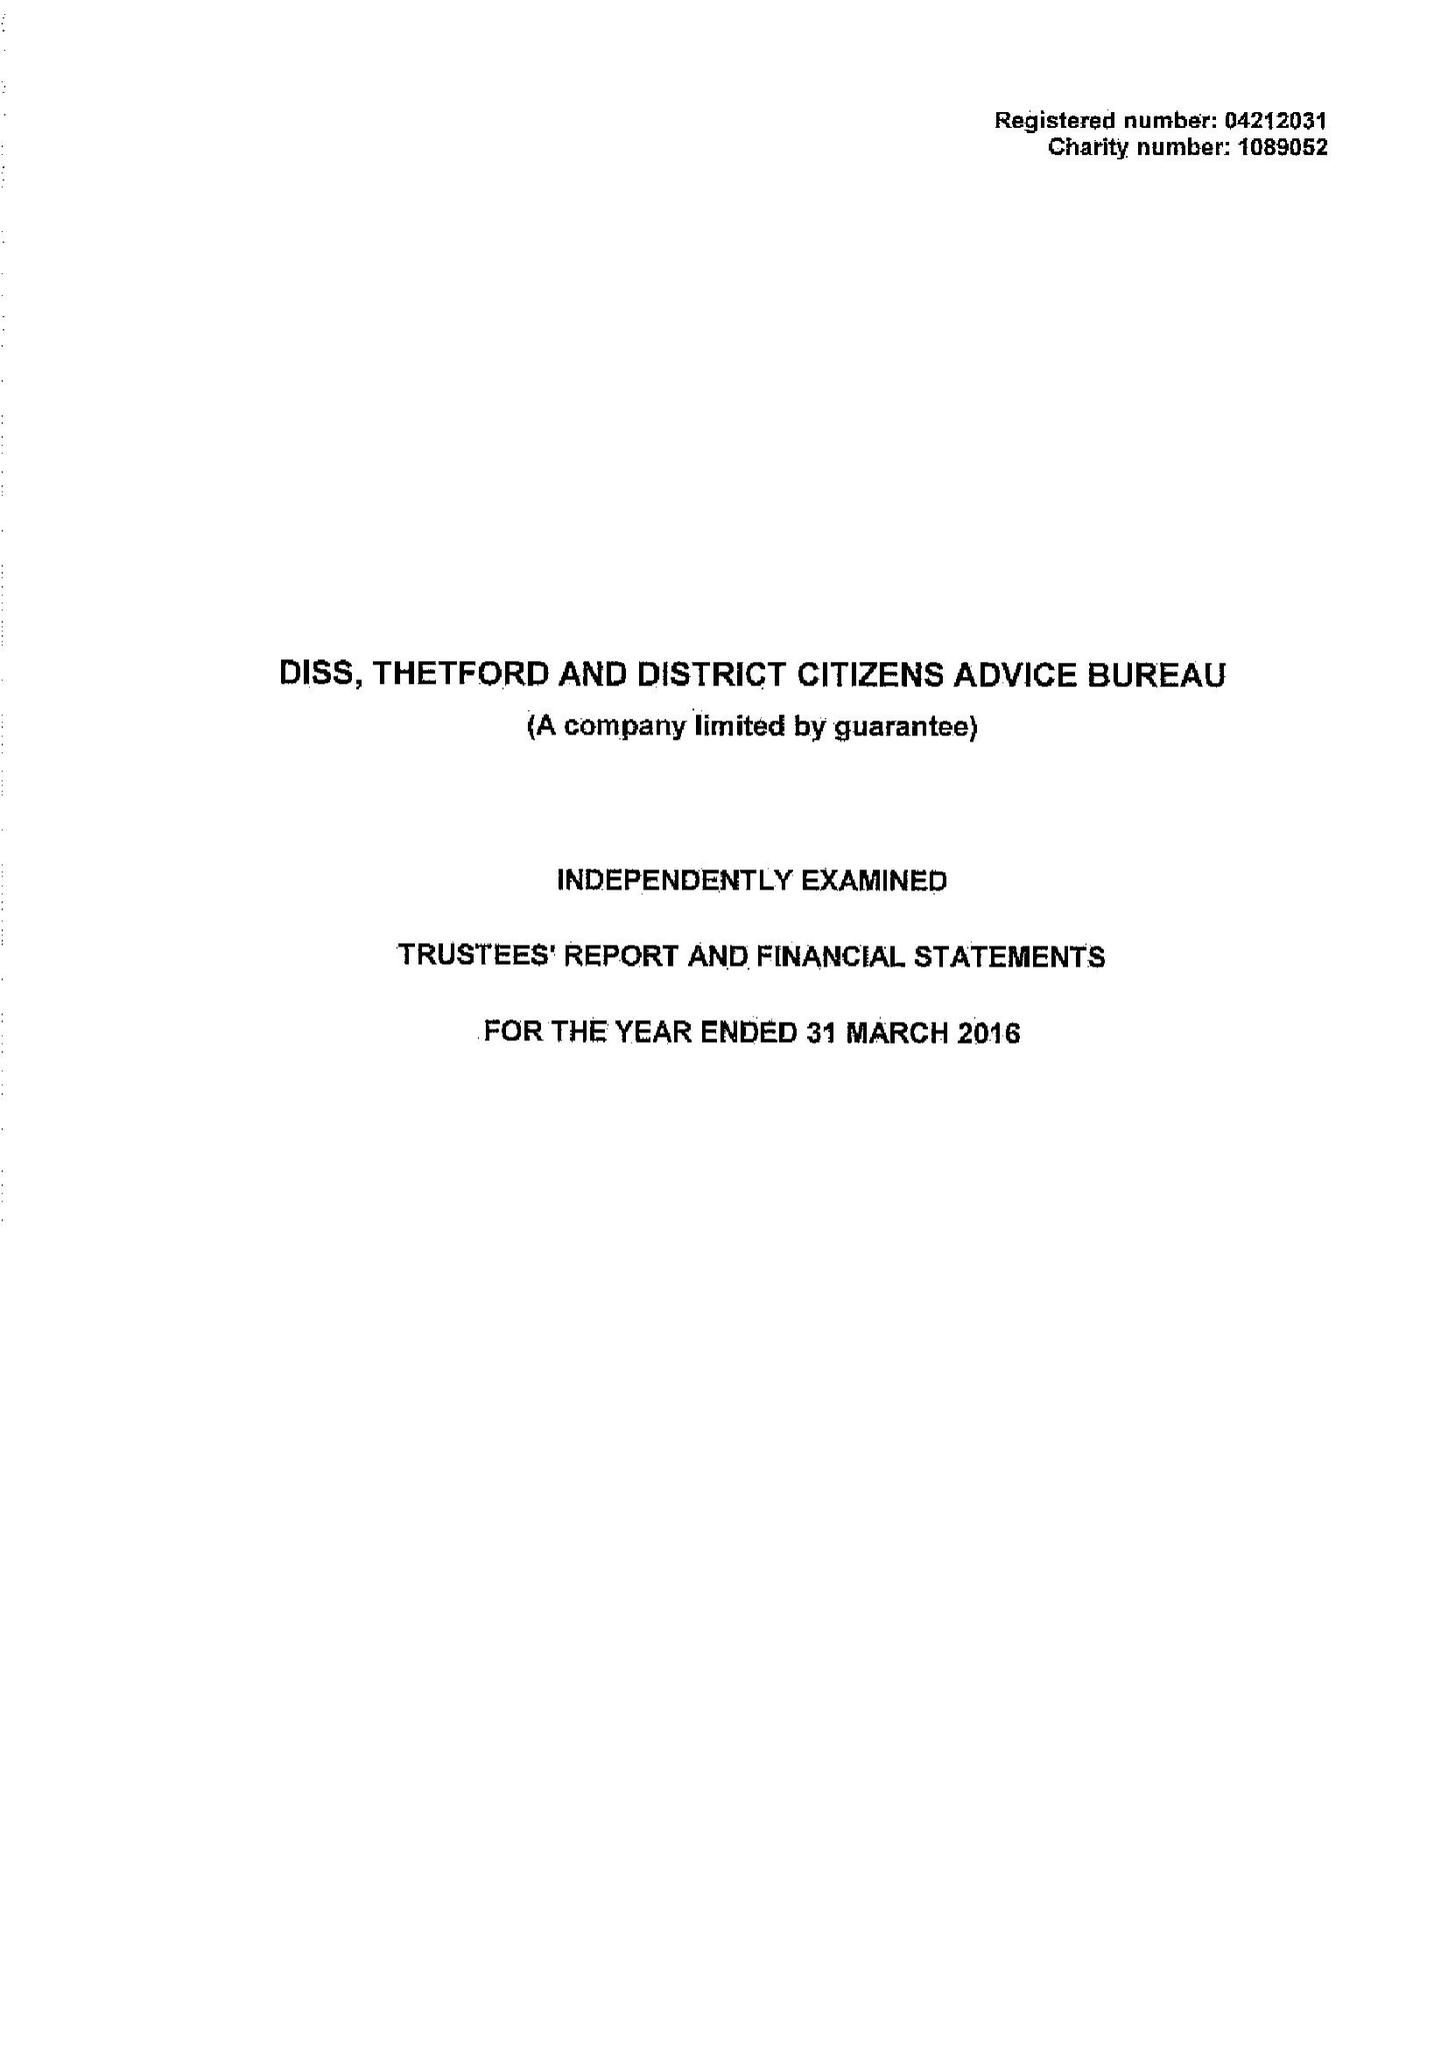What is the value for the address__post_town?
Answer the question using a single word or phrase. DISS 